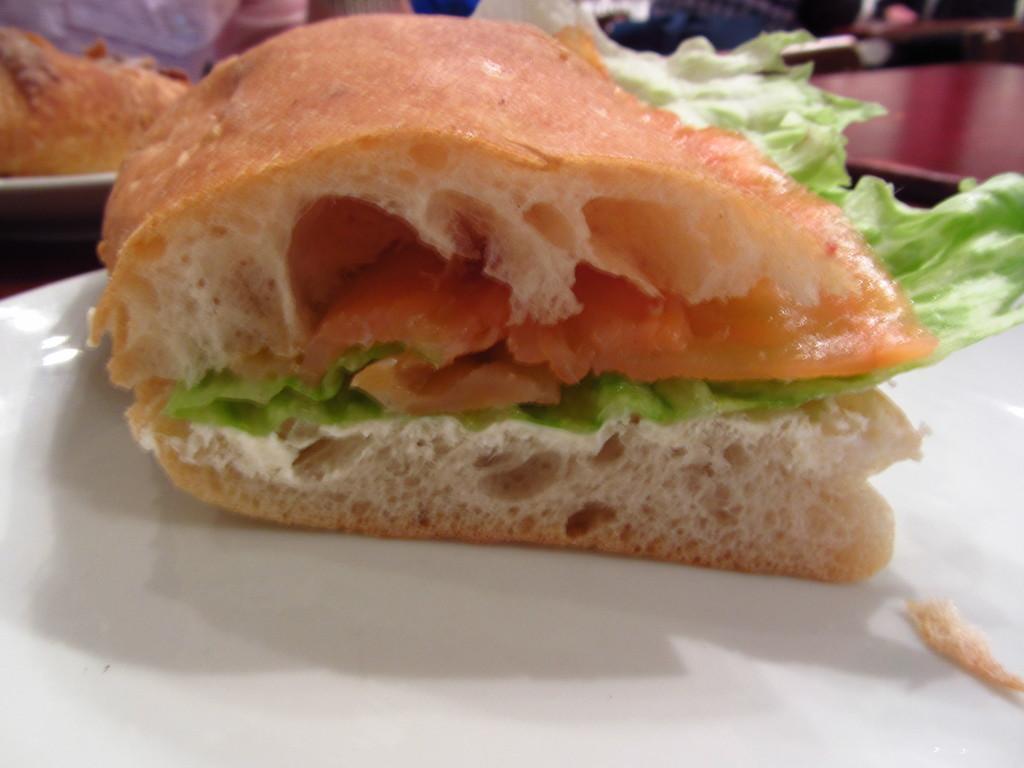Could you give a brief overview of what you see in this image? In this image I see white plates on which there is food which is of brown, red and green in color and I see the maroon color thing over here. 